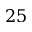<formula> <loc_0><loc_0><loc_500><loc_500>2 5</formula> 